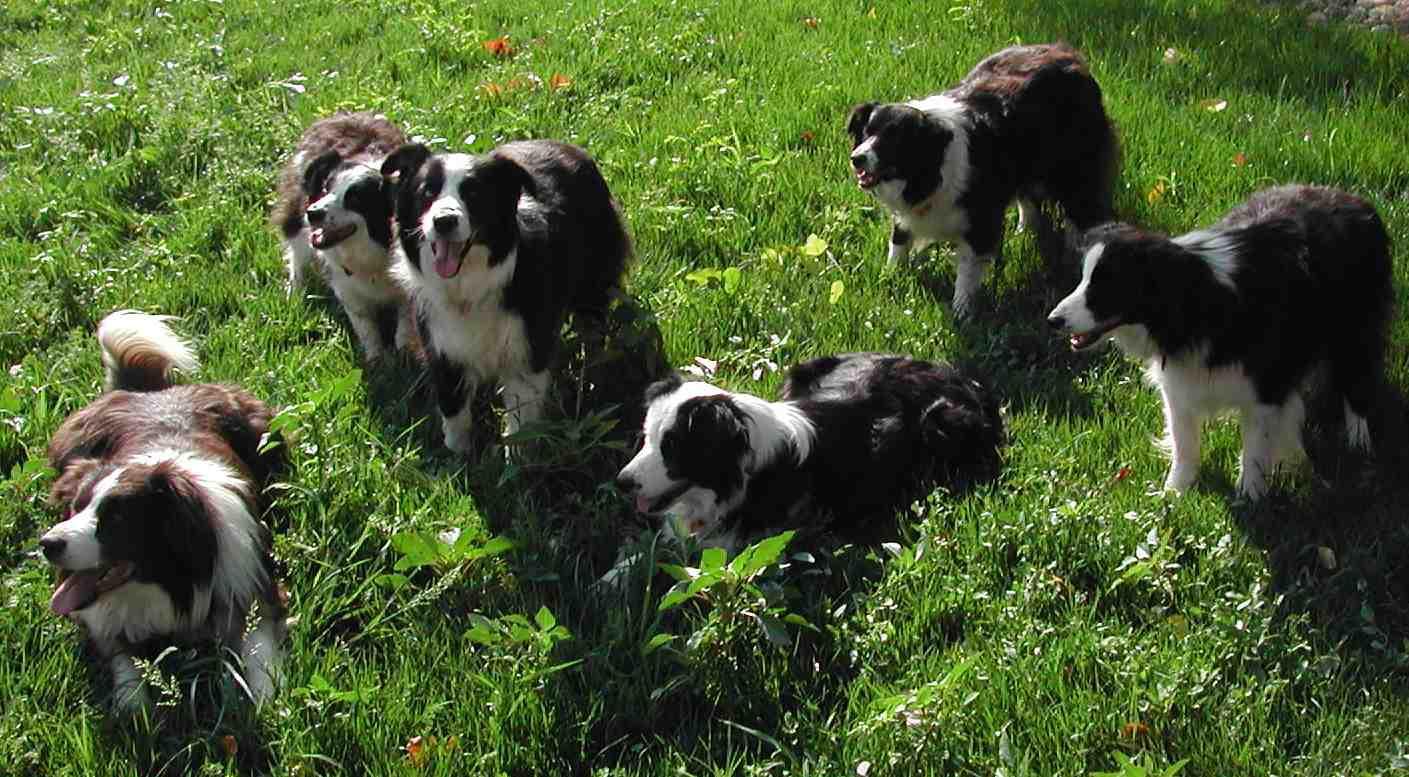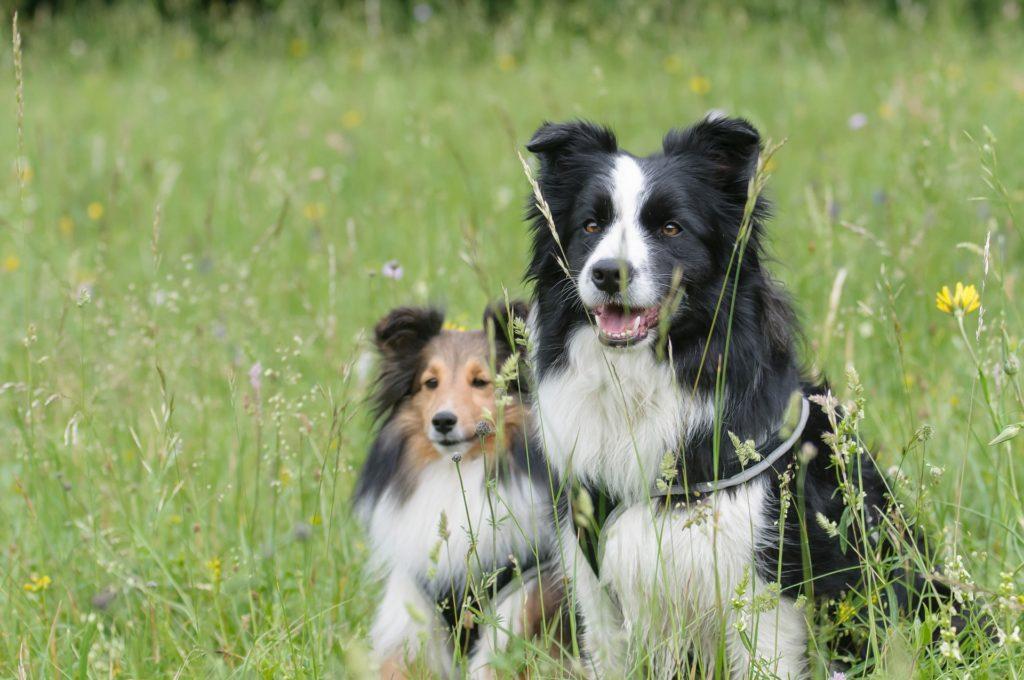The first image is the image on the left, the second image is the image on the right. Considering the images on both sides, is "The left image shows a dog running through grass while holding a toy in its mouth" valid? Answer yes or no. No. The first image is the image on the left, the second image is the image on the right. For the images displayed, is the sentence "An image shows one dog posed in the grass with a yellow ball." factually correct? Answer yes or no. No. 